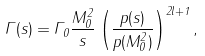<formula> <loc_0><loc_0><loc_500><loc_500>\Gamma ( s ) = \Gamma _ { 0 } \frac { M _ { 0 } ^ { 2 } } { s } \left ( \frac { p ( s ) } { p ( M ^ { 2 } _ { 0 } ) } \right ) ^ { 2 l + 1 } ,</formula> 